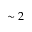<formula> <loc_0><loc_0><loc_500><loc_500>\sim 2</formula> 